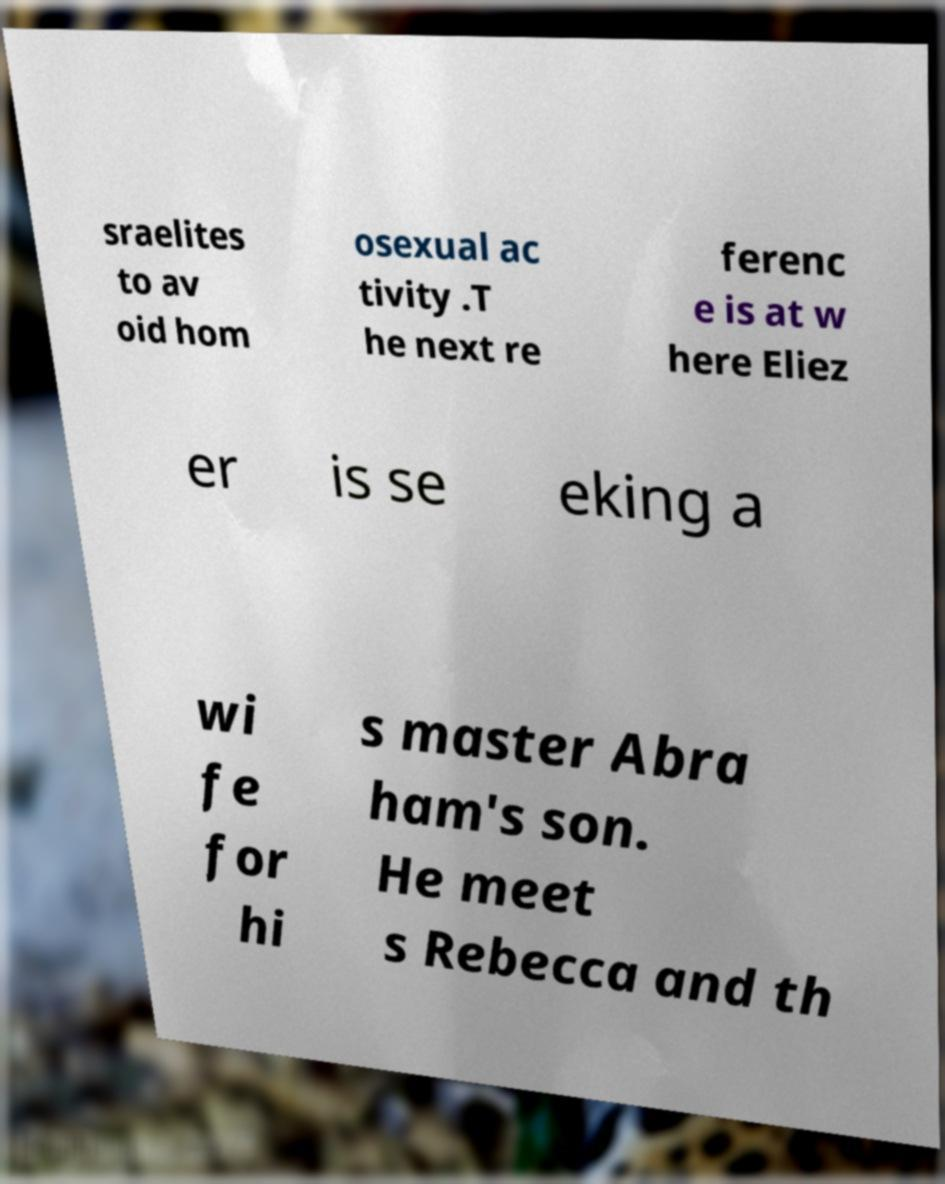Can you accurately transcribe the text from the provided image for me? sraelites to av oid hom osexual ac tivity .T he next re ferenc e is at w here Eliez er is se eking a wi fe for hi s master Abra ham's son. He meet s Rebecca and th 